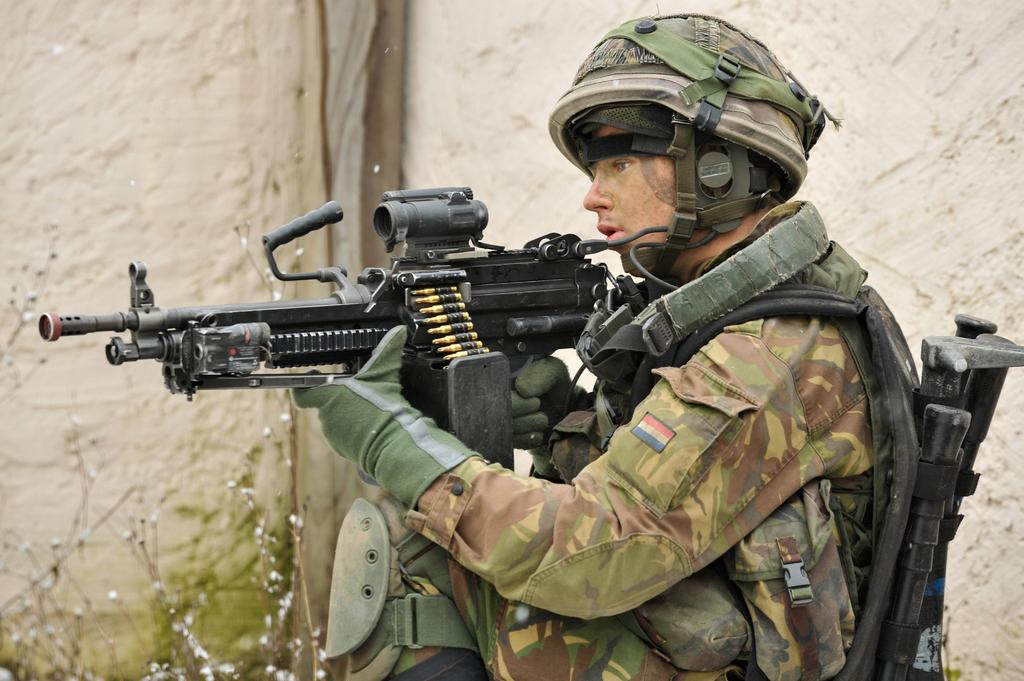What is the main subject of the image? The main subject of the image is a man. What is the man doing in the image? The man is standing in the image. What is the man holding in his hands? The man is holding a gun in his hands. What is the man wearing in the image? The man is wearing a uniform in the image. What type of vegetation can be seen in the image? There are plants in the image. What is visible in the background of the image? There is a wall in the background of the image. What type of tomatoes can be seen growing on the wall in the image? There are no tomatoes present in the image, and the wall does not have any plants growing on it. 